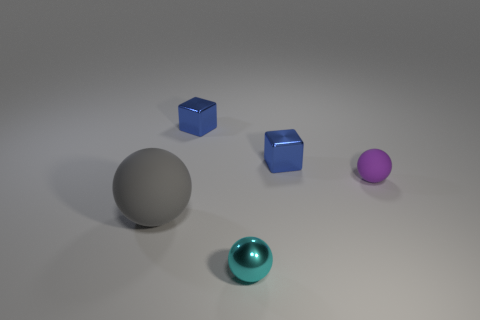There is a cyan object that is the same shape as the large gray rubber object; what is it made of?
Provide a short and direct response. Metal. Are there any other things that are made of the same material as the tiny purple thing?
Offer a terse response. Yes. What color is the small matte sphere?
Ensure brevity in your answer.  Purple. Is the color of the large ball the same as the tiny rubber sphere?
Your response must be concise. No. There is a matte thing in front of the purple ball; what number of purple rubber balls are on the left side of it?
Provide a succinct answer. 0. What is the size of the sphere that is to the right of the large gray rubber sphere and behind the cyan metal thing?
Give a very brief answer. Small. There is a sphere that is in front of the big thing; what is it made of?
Your response must be concise. Metal. Are there any large brown shiny objects of the same shape as the purple thing?
Offer a terse response. No. What number of yellow shiny objects are the same shape as the small cyan thing?
Make the answer very short. 0. Does the ball to the left of the small cyan metal thing have the same size as the metal thing that is to the right of the cyan metal object?
Ensure brevity in your answer.  No. 